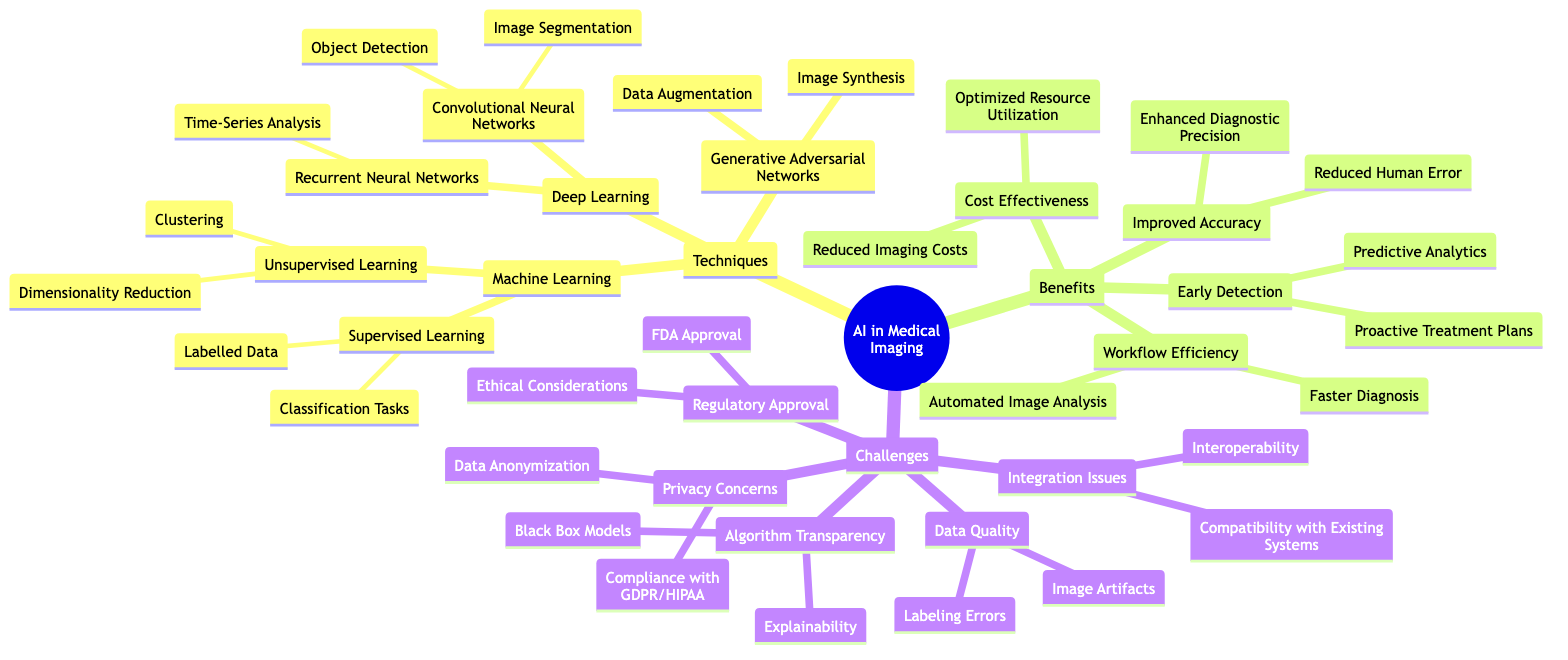What are the primary techniques used in the integration of AI in medical imaging? The diagram lists three primary techniques: Machine Learning, Deep Learning, and Generative Adversarial Networks, which are directly connected to the central topic.
Answer: Machine Learning, Deep Learning, Generative Adversarial Networks How many techniques are detailed in the diagram? By counting the branches under the "Techniques" section, we see there are three techniques provided: Machine Learning, Deep Learning, and Generative Adversarial Networks, which indicates a total of three techniques.
Answer: 3 What is one benefit related to improved accuracy? Under the "Benefits" section, one of the specified points related to improved accuracy is "Reduced Human Error," which emphasizes the specific advantage highlighted.
Answer: Reduced Human Error What challenge is associated with regulatory approval? The "Challenges" section lists "FDA Approval" and "Ethical Considerations" as aspects under regulatory approval, indicating the significant issues faced in this area.
Answer: FDA Approval Which technique includes image segmentation as an application? In the "Deep Learning" subsection of the diagram, "Convolutional Neural Networks" directly connects to "Image Segmentation," identifying it as an application of this technique.
Answer: Convolutional Neural Networks What is one benefit of workflow efficiency mentioned in the diagram? The diagram states "Faster Diagnosis" as a specific benefit under the "Workflow Efficiency" category, clearly showing an advantage in this area.
Answer: Faster Diagnosis Which subtopic contains points related to data quality? The "Challenges" section of the diagram includes "Data Quality" as a subtopic, indicating challenges posed in this field.
Answer: Challenges Explain the relationship between early detection and predictive analytics. "Early Detection" is a benefit listed in the diagram that includes "Predictive Analytics," suggesting that predictive analytics is a means to achieve early detection, tying the two concepts together logically.
Answer: Early Detection How does deep learning benefit medical imaging? The diagram connects "Deep Learning" to applications such as "Image Segmentation" and "Object Detection," indicating that deep learning enhances medical imaging by improving how images are interpreted and analyzed.
Answer: Enhanced Analysis What is the connection between privacy concerns and data anonymization? "Privacy Concerns" is listed as a challenge in the diagram directly linked to "Data Anonymization," indicating that concerns over privacy lead to the necessity of anonymizing data before use.
Answer: Data Anonymization 